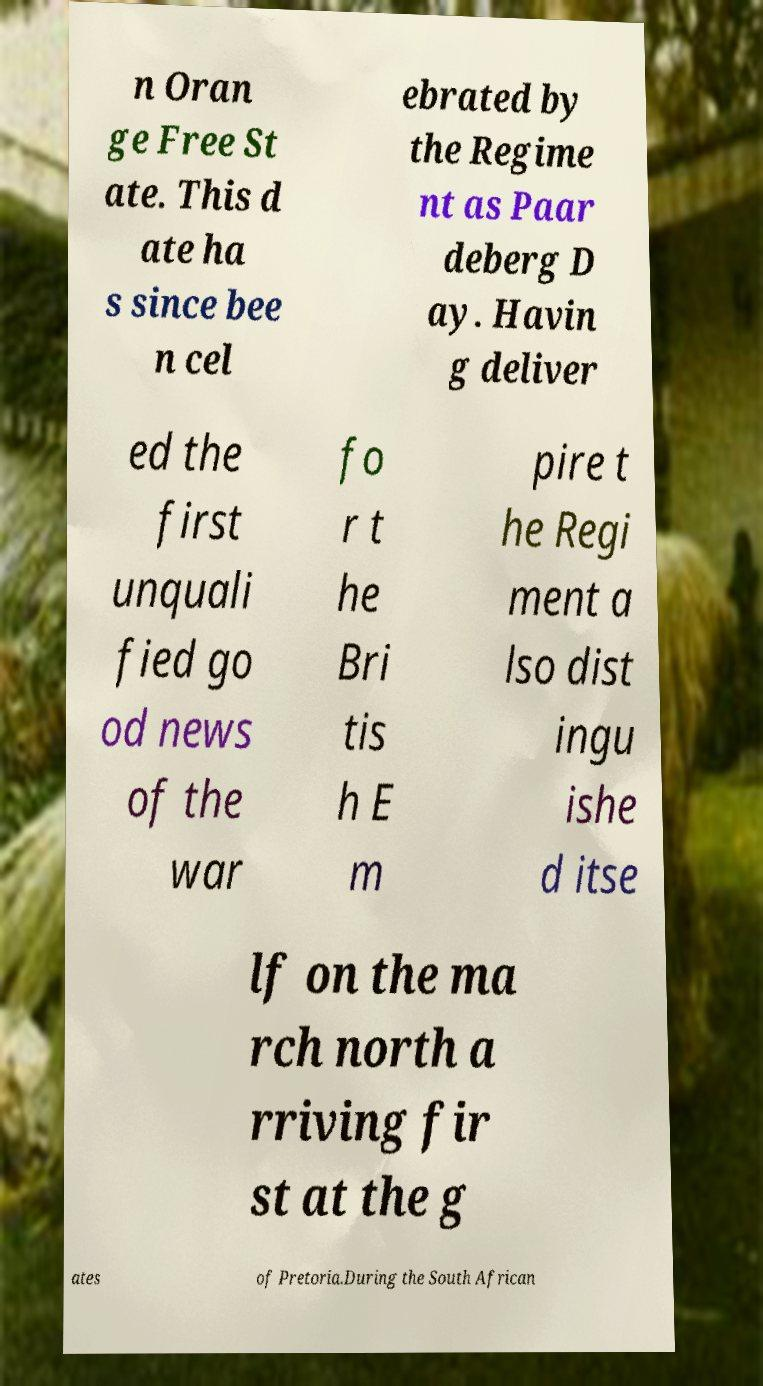Can you accurately transcribe the text from the provided image for me? n Oran ge Free St ate. This d ate ha s since bee n cel ebrated by the Regime nt as Paar deberg D ay. Havin g deliver ed the first unquali fied go od news of the war fo r t he Bri tis h E m pire t he Regi ment a lso dist ingu ishe d itse lf on the ma rch north a rriving fir st at the g ates of Pretoria.During the South African 